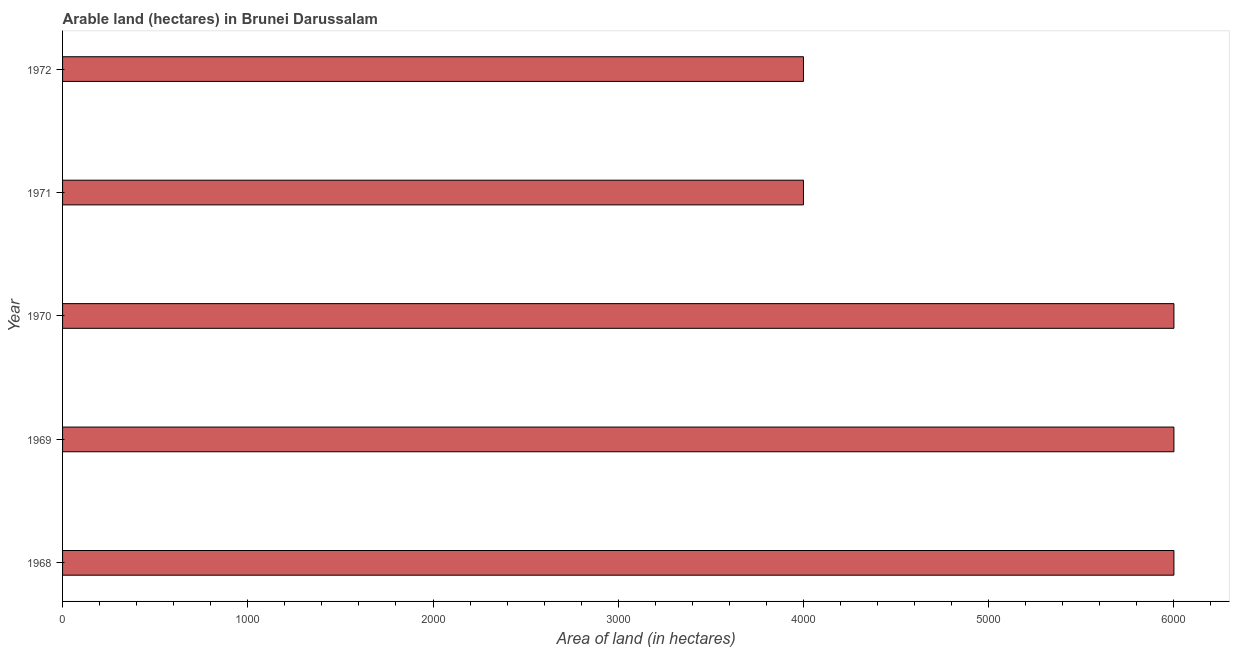Does the graph contain any zero values?
Provide a succinct answer. No. Does the graph contain grids?
Offer a very short reply. No. What is the title of the graph?
Keep it short and to the point. Arable land (hectares) in Brunei Darussalam. What is the label or title of the X-axis?
Provide a succinct answer. Area of land (in hectares). What is the label or title of the Y-axis?
Offer a very short reply. Year. What is the area of land in 1970?
Keep it short and to the point. 6000. Across all years, what is the maximum area of land?
Offer a terse response. 6000. Across all years, what is the minimum area of land?
Ensure brevity in your answer.  4000. In which year was the area of land maximum?
Keep it short and to the point. 1968. In which year was the area of land minimum?
Offer a terse response. 1971. What is the sum of the area of land?
Your answer should be compact. 2.60e+04. What is the difference between the area of land in 1971 and 1972?
Offer a terse response. 0. What is the average area of land per year?
Make the answer very short. 5200. What is the median area of land?
Provide a short and direct response. 6000. In how many years, is the area of land greater than 5000 hectares?
Provide a succinct answer. 3. What is the ratio of the area of land in 1969 to that in 1971?
Your response must be concise. 1.5. Is the difference between the area of land in 1969 and 1971 greater than the difference between any two years?
Ensure brevity in your answer.  Yes. Are all the bars in the graph horizontal?
Keep it short and to the point. Yes. How many years are there in the graph?
Provide a succinct answer. 5. What is the difference between two consecutive major ticks on the X-axis?
Ensure brevity in your answer.  1000. What is the Area of land (in hectares) of 1968?
Provide a short and direct response. 6000. What is the Area of land (in hectares) of 1969?
Keep it short and to the point. 6000. What is the Area of land (in hectares) in 1970?
Make the answer very short. 6000. What is the Area of land (in hectares) in 1971?
Keep it short and to the point. 4000. What is the Area of land (in hectares) of 1972?
Give a very brief answer. 4000. What is the difference between the Area of land (in hectares) in 1968 and 1969?
Your answer should be compact. 0. What is the difference between the Area of land (in hectares) in 1968 and 1970?
Your response must be concise. 0. What is the difference between the Area of land (in hectares) in 1968 and 1971?
Give a very brief answer. 2000. What is the difference between the Area of land (in hectares) in 1969 and 1971?
Your response must be concise. 2000. What is the difference between the Area of land (in hectares) in 1970 and 1971?
Ensure brevity in your answer.  2000. What is the ratio of the Area of land (in hectares) in 1968 to that in 1969?
Make the answer very short. 1. What is the ratio of the Area of land (in hectares) in 1968 to that in 1970?
Ensure brevity in your answer.  1. What is the ratio of the Area of land (in hectares) in 1968 to that in 1971?
Your answer should be compact. 1.5. What is the ratio of the Area of land (in hectares) in 1968 to that in 1972?
Provide a short and direct response. 1.5. What is the ratio of the Area of land (in hectares) in 1969 to that in 1970?
Give a very brief answer. 1. What is the ratio of the Area of land (in hectares) in 1969 to that in 1971?
Offer a very short reply. 1.5. What is the ratio of the Area of land (in hectares) in 1970 to that in 1972?
Offer a terse response. 1.5. What is the ratio of the Area of land (in hectares) in 1971 to that in 1972?
Your answer should be compact. 1. 